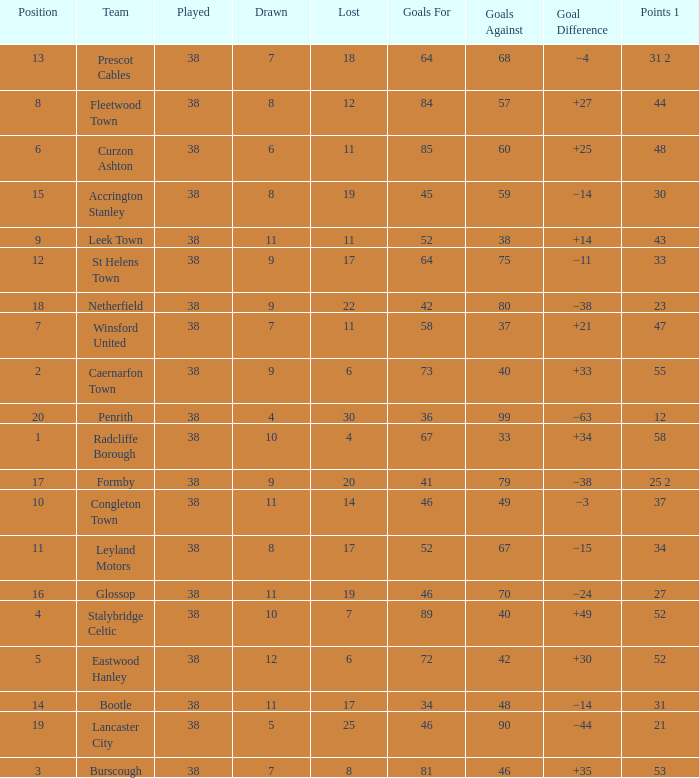WHAT IS THE LOST WITH A DRAWN 11, FOR LEEK TOWN? 11.0. 